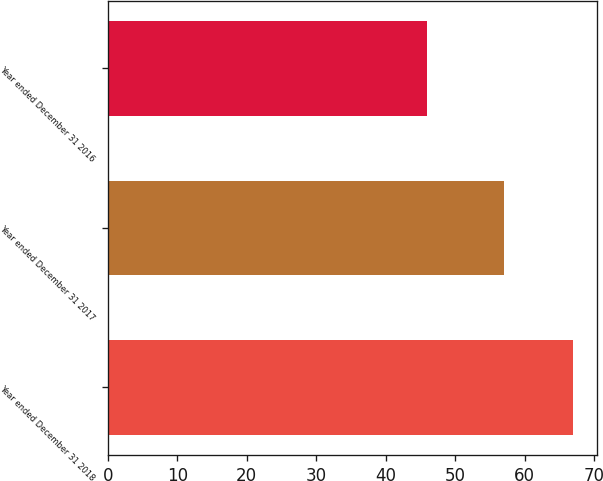Convert chart to OTSL. <chart><loc_0><loc_0><loc_500><loc_500><bar_chart><fcel>Year ended December 31 2018<fcel>Year ended December 31 2017<fcel>Year ended December 31 2016<nl><fcel>67<fcel>57<fcel>46<nl></chart> 